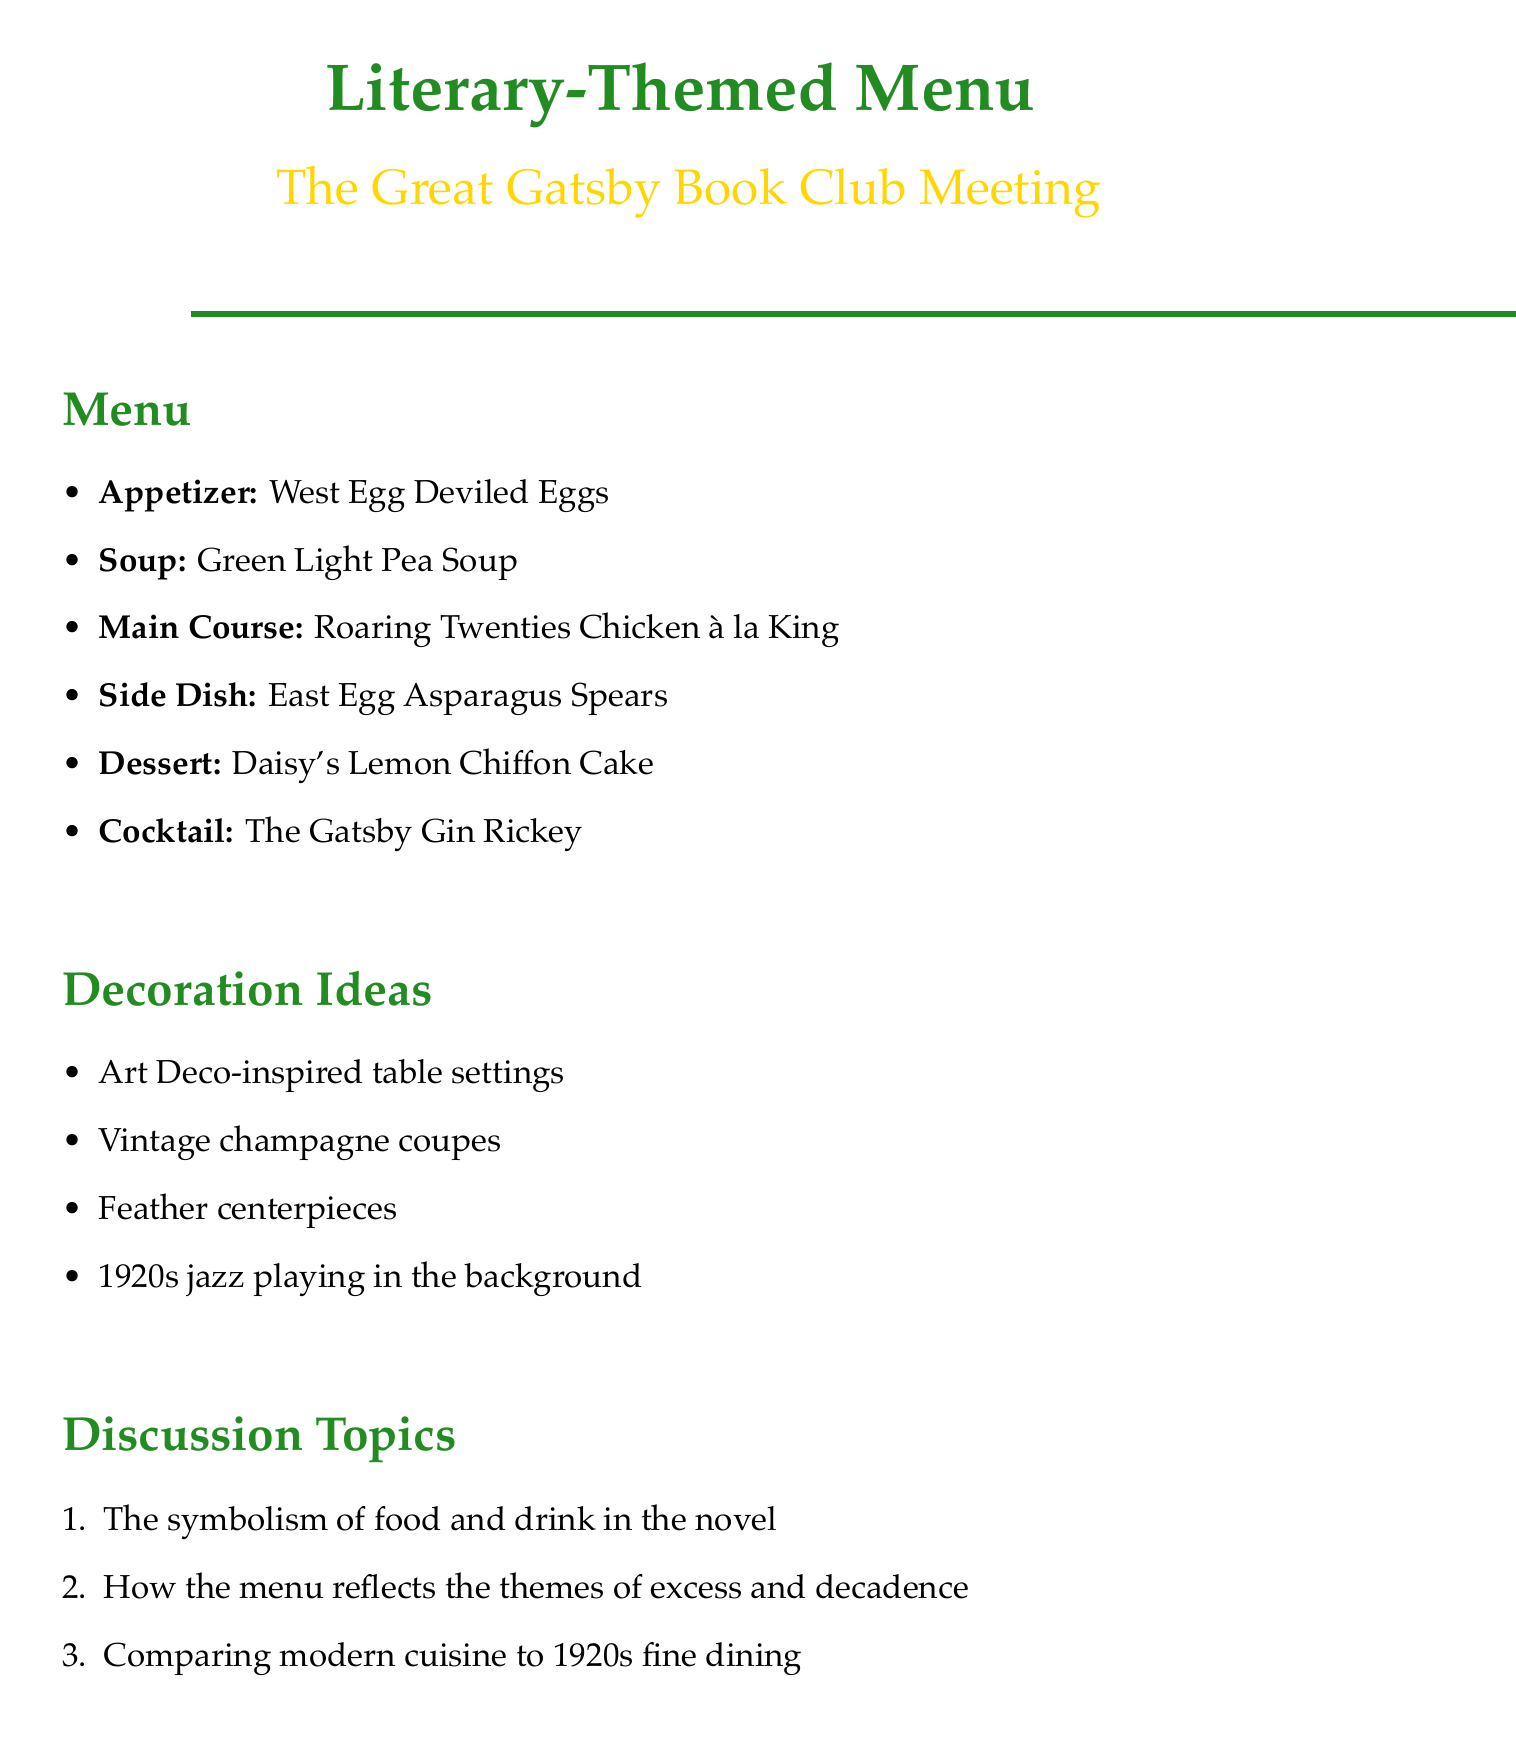What is the title of the memo? The title of the memo is provided at the beginning and serves as the main header, indicating the theme and purpose of the document.
Answer: Literary-Themed Menu for Next Month's Book Club Meeting Which book is the menu based on? The book selection mentioned in the memo indicates the literary work that inspires the menu for the upcoming book club meeting.
Answer: The Great Gatsby by F. Scott Fitzgerald What is the main course dish? The menu lists the various courses, with each dish corresponding to its respective category, including the main course which is specifically highlighted.
Answer: Roaring Twenties Chicken à la King What is included in the dessert? The dessert section specifies a unique dish that fits the theme of the book, providing insight into the menu's cohesion with literary elements.
Answer: Daisy's Lemon Chiffon Cake What type of decoration is suggested? The decoration ideas offer suggestions for creating an atmosphere that aligns with the themes of the book and enhances the dining experience for the club meeting.
Answer: Art Deco-inspired table settings Which discussion topic involves modern cuisine? The discussion topics present several ideas for conversation, with one specifically comparing past and present culinary practices as related to the book's themes.
Answer: Comparing modern cuisine to 1920s fine dining What dietary considerations are suggested? Additional notes address practical aspects of meal preparation and planning, including considerations for guests' various dietary needs during the event.
Answer: Consider dietary restrictions of book club members What drink is mentioned in the menu? The cocktail section of the menu includes a drink that is not only thematic but also directly referenced in the book, adding to the overall experience.
Answer: The Gatsby Gin Rickey 